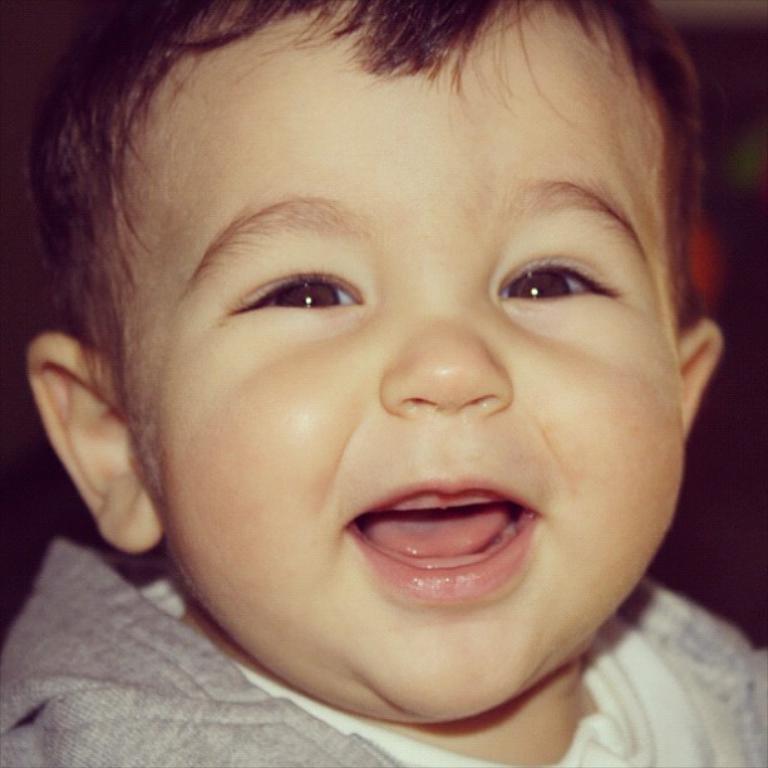Describe this image in one or two sentences. In the picture we can see a baby smiling and wearing a gray color T-shirt. 